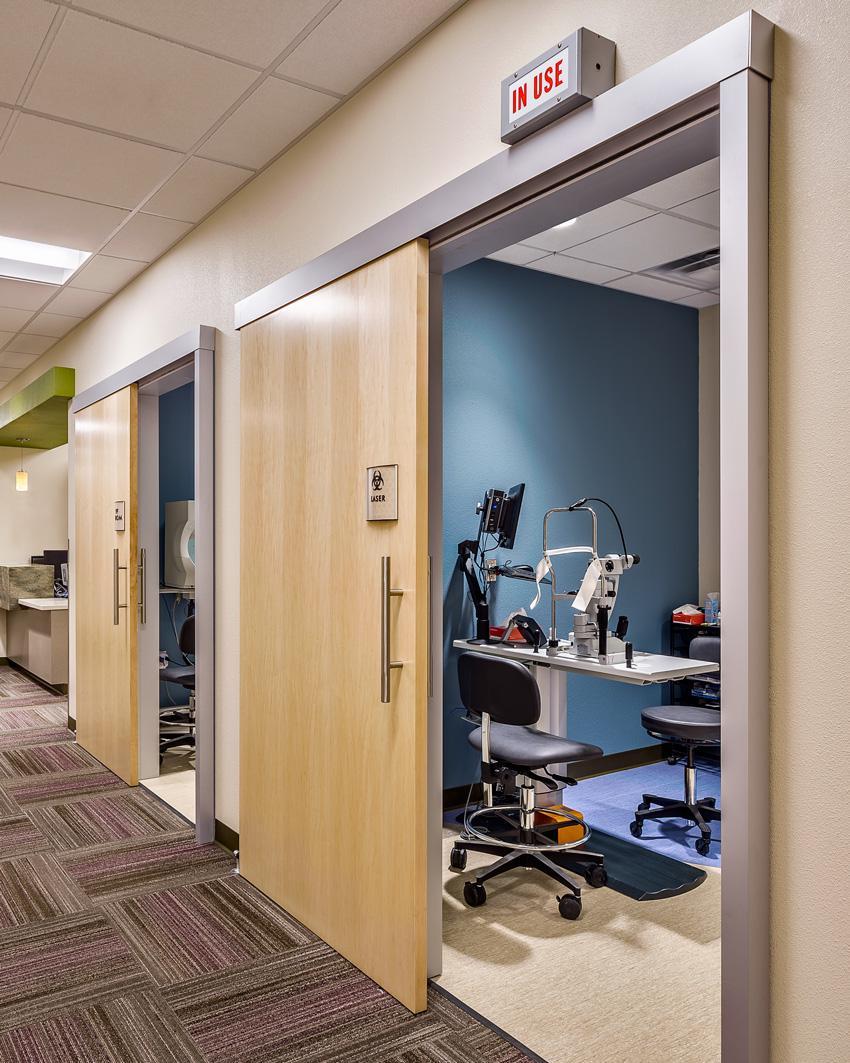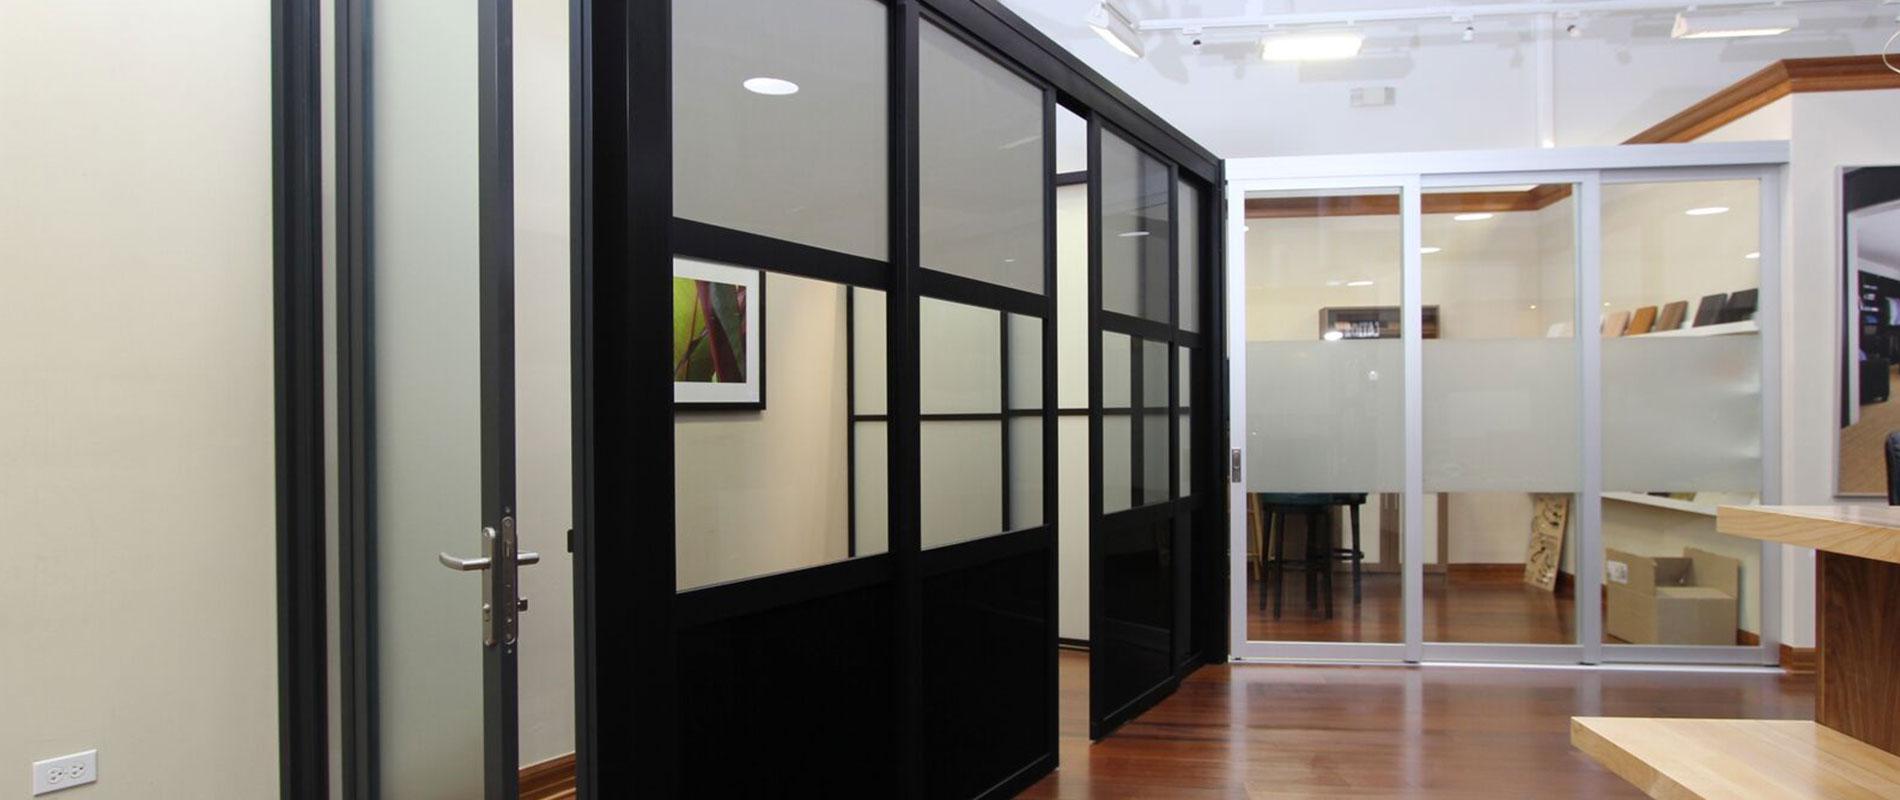The first image is the image on the left, the second image is the image on the right. Evaluate the accuracy of this statement regarding the images: "In at least one image there is a sliver elevator and the other image is ofwhite frame glass windows.". Is it true? Answer yes or no. No. The first image is the image on the left, the second image is the image on the right. For the images displayed, is the sentence "One image features silver elevator doors, and the other image features glass windows that reach nearly to the ceiling." factually correct? Answer yes or no. No. 